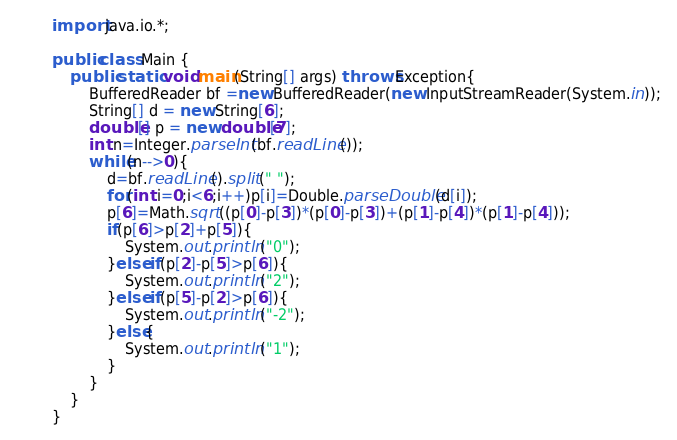<code> <loc_0><loc_0><loc_500><loc_500><_Java_>import java.io.*;

public class Main {
	public static void main(String[] args) throws Exception{
		BufferedReader bf =new BufferedReader(new InputStreamReader(System.in));
		String[] d = new String[6];
		double[] p = new double[7];
		int n=Integer.parseInt(bf.readLine());
		while(n-->0){
			d=bf.readLine().split(" ");
			for(int i=0;i<6;i++)p[i]=Double.parseDouble(d[i]);
			p[6]=Math.sqrt((p[0]-p[3])*(p[0]-p[3])+(p[1]-p[4])*(p[1]-p[4]));
			if(p[6]>p[2]+p[5]){
				System.out.println("0");
			}else if(p[2]-p[5]>p[6]){
				System.out.println("2");
			}else if(p[5]-p[2]>p[6]){
				System.out.println("-2");
			}else{
				System.out.println("1");
			}
		}
	}
}</code> 